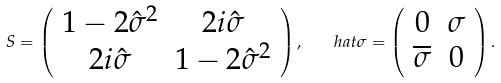<formula> <loc_0><loc_0><loc_500><loc_500>S = \left ( \begin{array} { c c } 1 - 2 \hat { \sigma } ^ { 2 } & 2 i \hat { \sigma } \\ 2 i \hat { \sigma } & 1 - 2 \hat { \sigma } ^ { 2 } \end{array} \right ) , \quad h a t { \sigma } = \left ( \begin{array} { c c } 0 & \sigma \\ \overline { \sigma } & 0 \end{array} \right ) .</formula> 